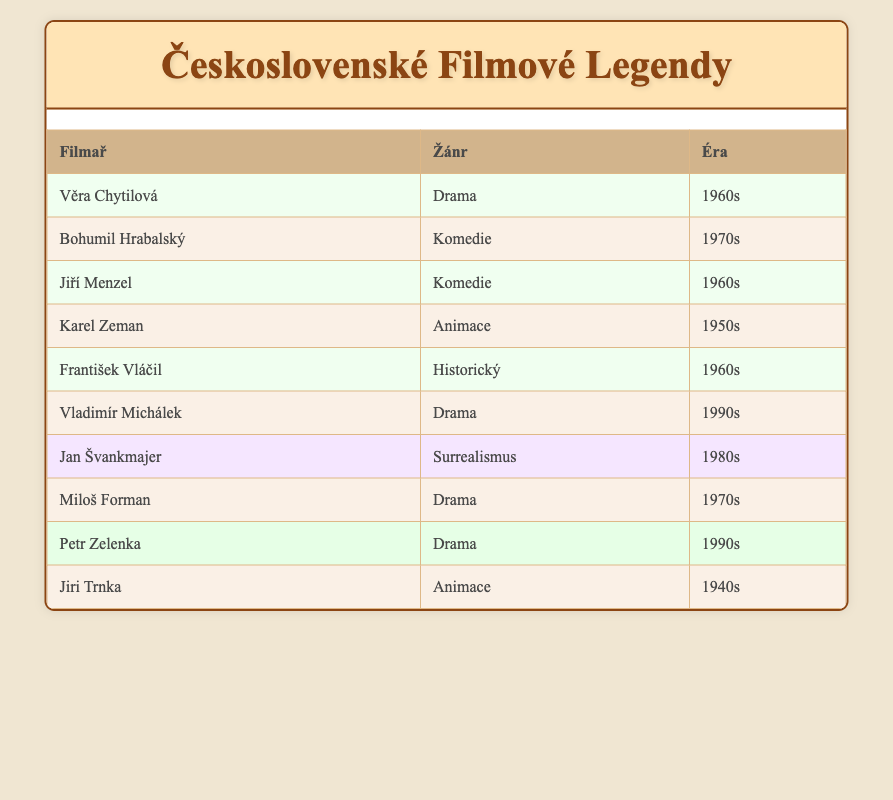What genre is Věra Chytilová associated with? By locating Věra Chytilová's entry in the table, we can see that she is listed under the genre "Drama."
Answer: Drama How many filmmakers are associated with the 1970s era? We look at the entries in the table for the 1970s. There are 3 entries: Bohumil Hrabalský, Miloš Forman, and one empty entry. Thus, the total is 3 filmmakers.
Answer: 3 Does Jiří Menzel work in the genre of Surrealism? The table lists Jiří Menzel under the genre "Comedy." Since he is not listed under Surrealism, the answer is no.
Answer: No What is the total number of Drama filmmakers in the 1990s? In the table, there are two entries for the 1990s that indicate the genre Drama: Vladimír Michálek and Petr Zelenka. Therefore, there are a total of 2 filmmakers in this genre and era.
Answer: 2 Which genre had the most representation in the 1960s? In the table, we identify the genres represented in the 1960s. The genres include Drama (Věra Chytilová), Comedy (Jiří Menzel), and Historical (František Vláčil). Therefore, we have one entry each for Comedy, Drama, and Historical, indicating that the representation is equal across genres in that era.
Answer: Equal representation How many animation filmmakers are from the 1950s or earlier? We find only one animator from the 1950s, Karel Zeman, and one from the 1940s, Jiři Trnka. Thus, the total is 2 animation filmmakers from those eras.
Answer: 2 True or False: Miloš Forman directed a film in the 1960s. The table shows that Miloš Forman is listed under the 1970s. Therefore, the statement is false.
Answer: False Which era has the most diverse genres represented in the table? To determine this, we analyze the genres per era. The 1960s have Drama, Comedy, and Historical, showing a mix of genres. In contrast, other eras have either just one genre or only up to two. Therefore, the 1960s has the most diverse representation of genres.
Answer: 1960s 